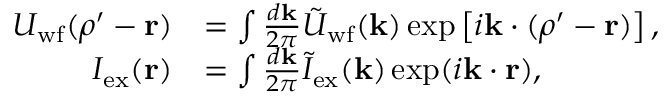<formula> <loc_0><loc_0><loc_500><loc_500>\begin{array} { r l } { U _ { w f } ( \rho ^ { \prime } - r ) } & { = \int \frac { d k } { 2 \pi } \tilde { U } _ { w f } ( k ) \exp \left [ i k \cdot ( \rho ^ { \prime } - r ) \right ] , } \\ { I _ { e x } ( r ) } & { = \int \frac { d k } { 2 \pi } \tilde { I } _ { e x } ( k ) \exp ( i k \cdot r ) , } \end{array}</formula> 